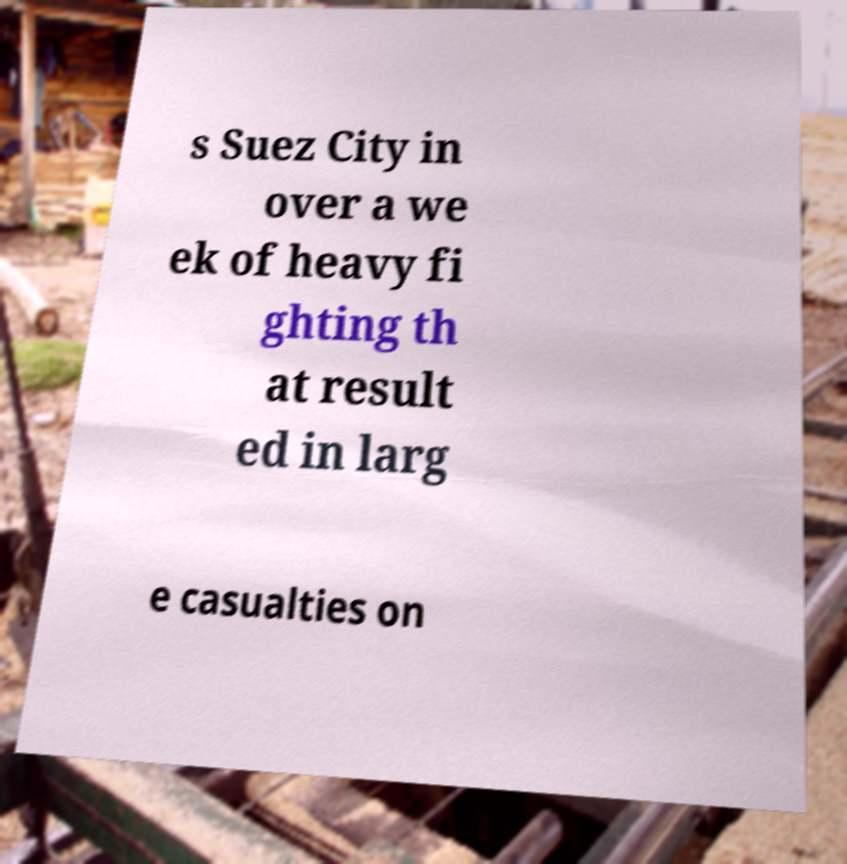Could you extract and type out the text from this image? s Suez City in over a we ek of heavy fi ghting th at result ed in larg e casualties on 